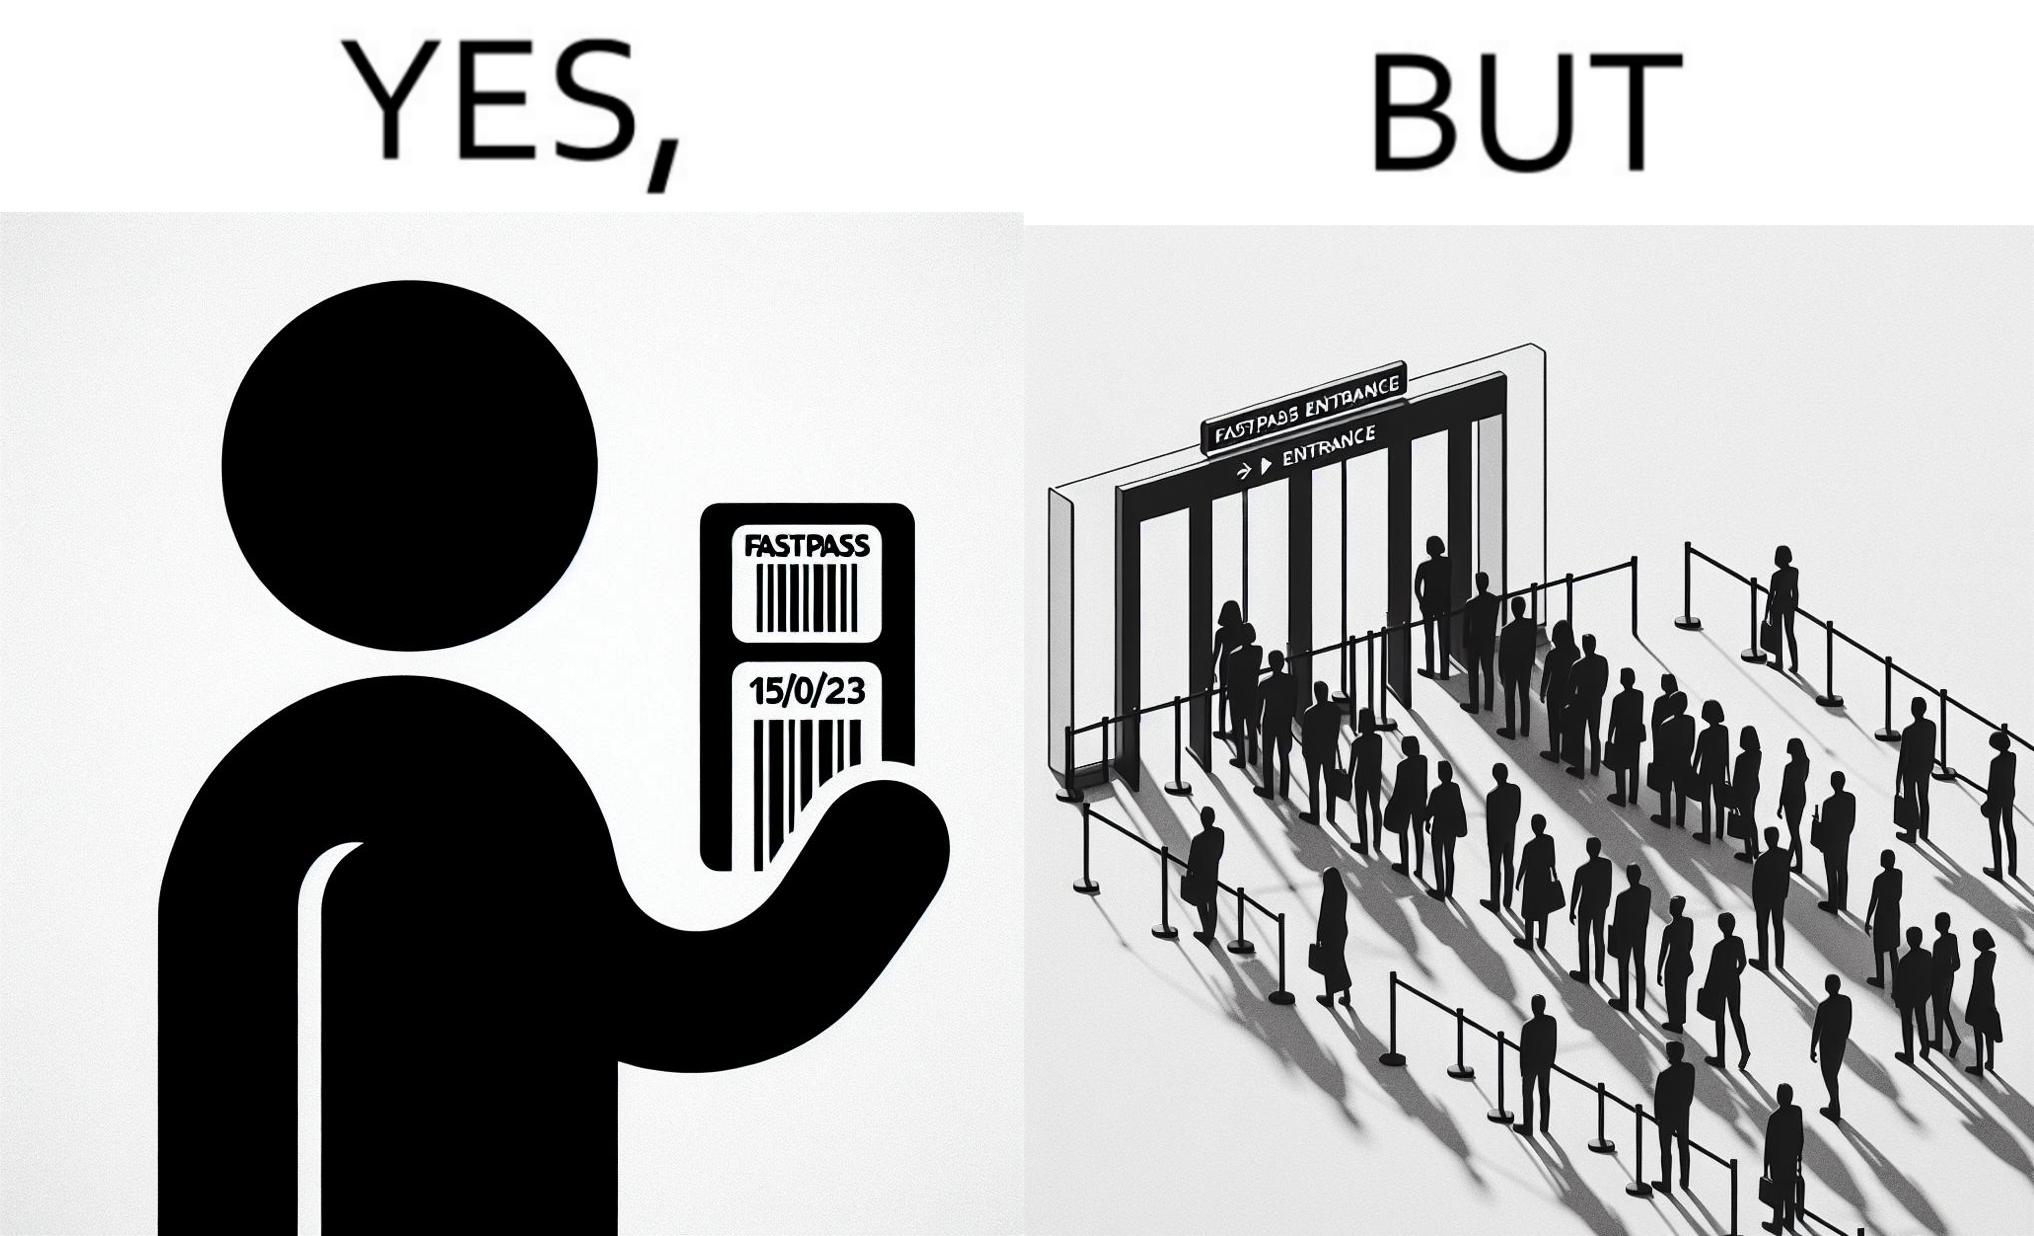Does this image contain satire or humor? Yes, this image is satirical. 